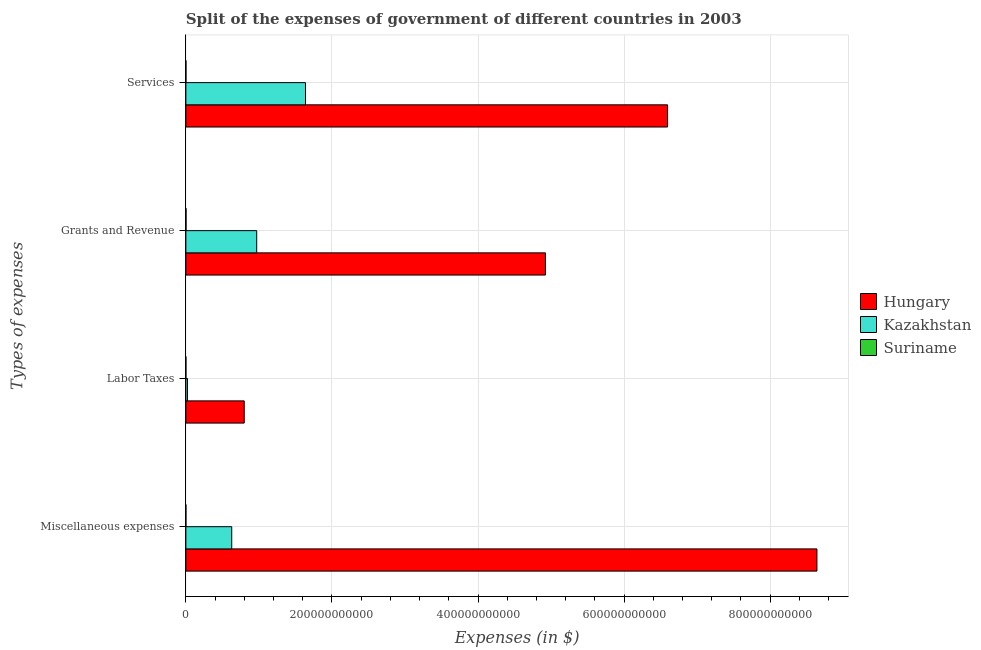What is the label of the 2nd group of bars from the top?
Ensure brevity in your answer.  Grants and Revenue. What is the amount spent on labor taxes in Hungary?
Make the answer very short. 7.99e+1. Across all countries, what is the maximum amount spent on services?
Provide a short and direct response. 6.60e+11. Across all countries, what is the minimum amount spent on labor taxes?
Ensure brevity in your answer.  3.84e+07. In which country was the amount spent on services maximum?
Give a very brief answer. Hungary. In which country was the amount spent on services minimum?
Offer a very short reply. Suriname. What is the total amount spent on miscellaneous expenses in the graph?
Offer a terse response. 9.27e+11. What is the difference between the amount spent on services in Hungary and that in Suriname?
Ensure brevity in your answer.  6.59e+11. What is the difference between the amount spent on grants and revenue in Hungary and the amount spent on services in Suriname?
Your answer should be compact. 4.92e+11. What is the average amount spent on services per country?
Give a very brief answer. 2.74e+11. What is the difference between the amount spent on services and amount spent on grants and revenue in Suriname?
Give a very brief answer. -1.07e+08. In how many countries, is the amount spent on services greater than 680000000000 $?
Offer a very short reply. 0. What is the ratio of the amount spent on labor taxes in Hungary to that in Suriname?
Provide a short and direct response. 2080.87. Is the amount spent on grants and revenue in Hungary less than that in Suriname?
Provide a short and direct response. No. Is the difference between the amount spent on grants and revenue in Hungary and Suriname greater than the difference between the amount spent on labor taxes in Hungary and Suriname?
Keep it short and to the point. Yes. What is the difference between the highest and the second highest amount spent on labor taxes?
Keep it short and to the point. 7.77e+1. What is the difference between the highest and the lowest amount spent on services?
Make the answer very short. 6.59e+11. In how many countries, is the amount spent on services greater than the average amount spent on services taken over all countries?
Provide a short and direct response. 1. Is the sum of the amount spent on services in Suriname and Hungary greater than the maximum amount spent on labor taxes across all countries?
Provide a short and direct response. Yes. Is it the case that in every country, the sum of the amount spent on services and amount spent on labor taxes is greater than the sum of amount spent on grants and revenue and amount spent on miscellaneous expenses?
Offer a terse response. No. What does the 3rd bar from the top in Grants and Revenue represents?
Your answer should be very brief. Hungary. What does the 3rd bar from the bottom in Services represents?
Give a very brief answer. Suriname. Are all the bars in the graph horizontal?
Give a very brief answer. Yes. What is the difference between two consecutive major ticks on the X-axis?
Give a very brief answer. 2.00e+11. What is the title of the graph?
Offer a terse response. Split of the expenses of government of different countries in 2003. Does "Panama" appear as one of the legend labels in the graph?
Ensure brevity in your answer.  No. What is the label or title of the X-axis?
Offer a terse response. Expenses (in $). What is the label or title of the Y-axis?
Ensure brevity in your answer.  Types of expenses. What is the Expenses (in $) in Hungary in Miscellaneous expenses?
Offer a very short reply. 8.64e+11. What is the Expenses (in $) of Kazakhstan in Miscellaneous expenses?
Your answer should be compact. 6.28e+1. What is the Expenses (in $) in Suriname in Miscellaneous expenses?
Make the answer very short. 4.59e+07. What is the Expenses (in $) in Hungary in Labor Taxes?
Keep it short and to the point. 7.99e+1. What is the Expenses (in $) of Kazakhstan in Labor Taxes?
Keep it short and to the point. 2.24e+09. What is the Expenses (in $) in Suriname in Labor Taxes?
Offer a terse response. 3.84e+07. What is the Expenses (in $) of Hungary in Grants and Revenue?
Ensure brevity in your answer.  4.92e+11. What is the Expenses (in $) of Kazakhstan in Grants and Revenue?
Your answer should be compact. 9.70e+1. What is the Expenses (in $) of Suriname in Grants and Revenue?
Your answer should be very brief. 2.09e+08. What is the Expenses (in $) of Hungary in Services?
Provide a succinct answer. 6.60e+11. What is the Expenses (in $) in Kazakhstan in Services?
Offer a terse response. 1.64e+11. What is the Expenses (in $) in Suriname in Services?
Your answer should be compact. 1.02e+08. Across all Types of expenses, what is the maximum Expenses (in $) in Hungary?
Provide a succinct answer. 8.64e+11. Across all Types of expenses, what is the maximum Expenses (in $) in Kazakhstan?
Offer a very short reply. 1.64e+11. Across all Types of expenses, what is the maximum Expenses (in $) of Suriname?
Give a very brief answer. 2.09e+08. Across all Types of expenses, what is the minimum Expenses (in $) in Hungary?
Provide a succinct answer. 7.99e+1. Across all Types of expenses, what is the minimum Expenses (in $) in Kazakhstan?
Offer a terse response. 2.24e+09. Across all Types of expenses, what is the minimum Expenses (in $) in Suriname?
Your response must be concise. 3.84e+07. What is the total Expenses (in $) in Hungary in the graph?
Keep it short and to the point. 2.10e+12. What is the total Expenses (in $) of Kazakhstan in the graph?
Give a very brief answer. 3.26e+11. What is the total Expenses (in $) of Suriname in the graph?
Provide a succinct answer. 3.95e+08. What is the difference between the Expenses (in $) of Hungary in Miscellaneous expenses and that in Labor Taxes?
Your answer should be compact. 7.84e+11. What is the difference between the Expenses (in $) in Kazakhstan in Miscellaneous expenses and that in Labor Taxes?
Ensure brevity in your answer.  6.06e+1. What is the difference between the Expenses (in $) of Suriname in Miscellaneous expenses and that in Labor Taxes?
Offer a very short reply. 7.46e+06. What is the difference between the Expenses (in $) of Hungary in Miscellaneous expenses and that in Grants and Revenue?
Your response must be concise. 3.72e+11. What is the difference between the Expenses (in $) of Kazakhstan in Miscellaneous expenses and that in Grants and Revenue?
Your response must be concise. -3.42e+1. What is the difference between the Expenses (in $) of Suriname in Miscellaneous expenses and that in Grants and Revenue?
Offer a very short reply. -1.63e+08. What is the difference between the Expenses (in $) of Hungary in Miscellaneous expenses and that in Services?
Ensure brevity in your answer.  2.04e+11. What is the difference between the Expenses (in $) in Kazakhstan in Miscellaneous expenses and that in Services?
Provide a short and direct response. -1.01e+11. What is the difference between the Expenses (in $) of Suriname in Miscellaneous expenses and that in Services?
Offer a very short reply. -5.63e+07. What is the difference between the Expenses (in $) in Hungary in Labor Taxes and that in Grants and Revenue?
Your answer should be very brief. -4.12e+11. What is the difference between the Expenses (in $) of Kazakhstan in Labor Taxes and that in Grants and Revenue?
Offer a very short reply. -9.47e+1. What is the difference between the Expenses (in $) of Suriname in Labor Taxes and that in Grants and Revenue?
Your response must be concise. -1.70e+08. What is the difference between the Expenses (in $) of Hungary in Labor Taxes and that in Services?
Ensure brevity in your answer.  -5.80e+11. What is the difference between the Expenses (in $) of Kazakhstan in Labor Taxes and that in Services?
Your answer should be very brief. -1.62e+11. What is the difference between the Expenses (in $) in Suriname in Labor Taxes and that in Services?
Give a very brief answer. -6.38e+07. What is the difference between the Expenses (in $) in Hungary in Grants and Revenue and that in Services?
Offer a very short reply. -1.67e+11. What is the difference between the Expenses (in $) in Kazakhstan in Grants and Revenue and that in Services?
Give a very brief answer. -6.68e+1. What is the difference between the Expenses (in $) in Suriname in Grants and Revenue and that in Services?
Ensure brevity in your answer.  1.07e+08. What is the difference between the Expenses (in $) of Hungary in Miscellaneous expenses and the Expenses (in $) of Kazakhstan in Labor Taxes?
Your answer should be very brief. 8.62e+11. What is the difference between the Expenses (in $) in Hungary in Miscellaneous expenses and the Expenses (in $) in Suriname in Labor Taxes?
Keep it short and to the point. 8.64e+11. What is the difference between the Expenses (in $) in Kazakhstan in Miscellaneous expenses and the Expenses (in $) in Suriname in Labor Taxes?
Offer a very short reply. 6.28e+1. What is the difference between the Expenses (in $) in Hungary in Miscellaneous expenses and the Expenses (in $) in Kazakhstan in Grants and Revenue?
Give a very brief answer. 7.67e+11. What is the difference between the Expenses (in $) of Hungary in Miscellaneous expenses and the Expenses (in $) of Suriname in Grants and Revenue?
Make the answer very short. 8.64e+11. What is the difference between the Expenses (in $) in Kazakhstan in Miscellaneous expenses and the Expenses (in $) in Suriname in Grants and Revenue?
Offer a very short reply. 6.26e+1. What is the difference between the Expenses (in $) in Hungary in Miscellaneous expenses and the Expenses (in $) in Kazakhstan in Services?
Ensure brevity in your answer.  7.00e+11. What is the difference between the Expenses (in $) of Hungary in Miscellaneous expenses and the Expenses (in $) of Suriname in Services?
Keep it short and to the point. 8.64e+11. What is the difference between the Expenses (in $) of Kazakhstan in Miscellaneous expenses and the Expenses (in $) of Suriname in Services?
Your answer should be compact. 6.27e+1. What is the difference between the Expenses (in $) of Hungary in Labor Taxes and the Expenses (in $) of Kazakhstan in Grants and Revenue?
Provide a short and direct response. -1.71e+1. What is the difference between the Expenses (in $) of Hungary in Labor Taxes and the Expenses (in $) of Suriname in Grants and Revenue?
Your answer should be compact. 7.97e+1. What is the difference between the Expenses (in $) of Kazakhstan in Labor Taxes and the Expenses (in $) of Suriname in Grants and Revenue?
Your response must be concise. 2.03e+09. What is the difference between the Expenses (in $) in Hungary in Labor Taxes and the Expenses (in $) in Kazakhstan in Services?
Keep it short and to the point. -8.39e+1. What is the difference between the Expenses (in $) in Hungary in Labor Taxes and the Expenses (in $) in Suriname in Services?
Make the answer very short. 7.98e+1. What is the difference between the Expenses (in $) of Kazakhstan in Labor Taxes and the Expenses (in $) of Suriname in Services?
Your answer should be very brief. 2.13e+09. What is the difference between the Expenses (in $) in Hungary in Grants and Revenue and the Expenses (in $) in Kazakhstan in Services?
Give a very brief answer. 3.28e+11. What is the difference between the Expenses (in $) in Hungary in Grants and Revenue and the Expenses (in $) in Suriname in Services?
Ensure brevity in your answer.  4.92e+11. What is the difference between the Expenses (in $) in Kazakhstan in Grants and Revenue and the Expenses (in $) in Suriname in Services?
Offer a terse response. 9.69e+1. What is the average Expenses (in $) of Hungary per Types of expenses?
Offer a very short reply. 5.24e+11. What is the average Expenses (in $) of Kazakhstan per Types of expenses?
Offer a terse response. 8.14e+1. What is the average Expenses (in $) in Suriname per Types of expenses?
Give a very brief answer. 9.88e+07. What is the difference between the Expenses (in $) of Hungary and Expenses (in $) of Kazakhstan in Miscellaneous expenses?
Your response must be concise. 8.01e+11. What is the difference between the Expenses (in $) in Hungary and Expenses (in $) in Suriname in Miscellaneous expenses?
Make the answer very short. 8.64e+11. What is the difference between the Expenses (in $) of Kazakhstan and Expenses (in $) of Suriname in Miscellaneous expenses?
Your answer should be compact. 6.27e+1. What is the difference between the Expenses (in $) in Hungary and Expenses (in $) in Kazakhstan in Labor Taxes?
Keep it short and to the point. 7.77e+1. What is the difference between the Expenses (in $) of Hungary and Expenses (in $) of Suriname in Labor Taxes?
Make the answer very short. 7.99e+1. What is the difference between the Expenses (in $) in Kazakhstan and Expenses (in $) in Suriname in Labor Taxes?
Your response must be concise. 2.20e+09. What is the difference between the Expenses (in $) of Hungary and Expenses (in $) of Kazakhstan in Grants and Revenue?
Give a very brief answer. 3.95e+11. What is the difference between the Expenses (in $) in Hungary and Expenses (in $) in Suriname in Grants and Revenue?
Provide a short and direct response. 4.92e+11. What is the difference between the Expenses (in $) in Kazakhstan and Expenses (in $) in Suriname in Grants and Revenue?
Keep it short and to the point. 9.68e+1. What is the difference between the Expenses (in $) of Hungary and Expenses (in $) of Kazakhstan in Services?
Provide a succinct answer. 4.96e+11. What is the difference between the Expenses (in $) of Hungary and Expenses (in $) of Suriname in Services?
Offer a terse response. 6.59e+11. What is the difference between the Expenses (in $) of Kazakhstan and Expenses (in $) of Suriname in Services?
Offer a terse response. 1.64e+11. What is the ratio of the Expenses (in $) in Hungary in Miscellaneous expenses to that in Labor Taxes?
Provide a short and direct response. 10.81. What is the ratio of the Expenses (in $) in Kazakhstan in Miscellaneous expenses to that in Labor Taxes?
Provide a short and direct response. 28.09. What is the ratio of the Expenses (in $) of Suriname in Miscellaneous expenses to that in Labor Taxes?
Keep it short and to the point. 1.19. What is the ratio of the Expenses (in $) in Hungary in Miscellaneous expenses to that in Grants and Revenue?
Ensure brevity in your answer.  1.76. What is the ratio of the Expenses (in $) of Kazakhstan in Miscellaneous expenses to that in Grants and Revenue?
Provide a succinct answer. 0.65. What is the ratio of the Expenses (in $) of Suriname in Miscellaneous expenses to that in Grants and Revenue?
Give a very brief answer. 0.22. What is the ratio of the Expenses (in $) of Hungary in Miscellaneous expenses to that in Services?
Provide a short and direct response. 1.31. What is the ratio of the Expenses (in $) of Kazakhstan in Miscellaneous expenses to that in Services?
Your response must be concise. 0.38. What is the ratio of the Expenses (in $) in Suriname in Miscellaneous expenses to that in Services?
Give a very brief answer. 0.45. What is the ratio of the Expenses (in $) of Hungary in Labor Taxes to that in Grants and Revenue?
Offer a very short reply. 0.16. What is the ratio of the Expenses (in $) in Kazakhstan in Labor Taxes to that in Grants and Revenue?
Your response must be concise. 0.02. What is the ratio of the Expenses (in $) of Suriname in Labor Taxes to that in Grants and Revenue?
Keep it short and to the point. 0.18. What is the ratio of the Expenses (in $) of Hungary in Labor Taxes to that in Services?
Make the answer very short. 0.12. What is the ratio of the Expenses (in $) in Kazakhstan in Labor Taxes to that in Services?
Offer a very short reply. 0.01. What is the ratio of the Expenses (in $) in Suriname in Labor Taxes to that in Services?
Offer a terse response. 0.38. What is the ratio of the Expenses (in $) in Hungary in Grants and Revenue to that in Services?
Your response must be concise. 0.75. What is the ratio of the Expenses (in $) of Kazakhstan in Grants and Revenue to that in Services?
Give a very brief answer. 0.59. What is the ratio of the Expenses (in $) of Suriname in Grants and Revenue to that in Services?
Give a very brief answer. 2.04. What is the difference between the highest and the second highest Expenses (in $) of Hungary?
Your response must be concise. 2.04e+11. What is the difference between the highest and the second highest Expenses (in $) of Kazakhstan?
Keep it short and to the point. 6.68e+1. What is the difference between the highest and the second highest Expenses (in $) of Suriname?
Offer a very short reply. 1.07e+08. What is the difference between the highest and the lowest Expenses (in $) of Hungary?
Make the answer very short. 7.84e+11. What is the difference between the highest and the lowest Expenses (in $) in Kazakhstan?
Provide a short and direct response. 1.62e+11. What is the difference between the highest and the lowest Expenses (in $) in Suriname?
Make the answer very short. 1.70e+08. 